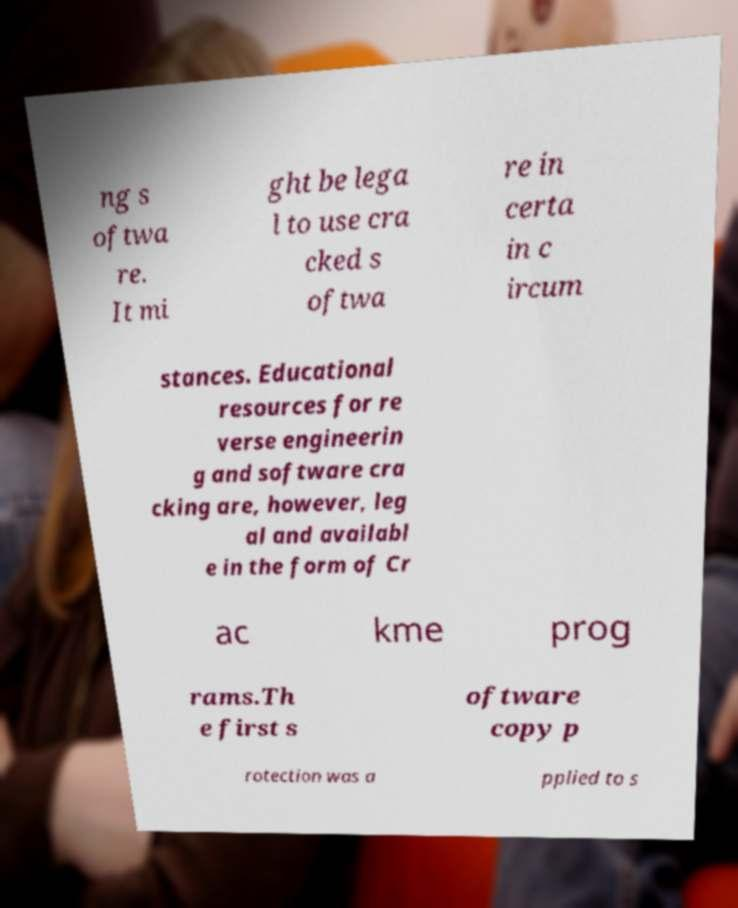Could you extract and type out the text from this image? ng s oftwa re. It mi ght be lega l to use cra cked s oftwa re in certa in c ircum stances. Educational resources for re verse engineerin g and software cra cking are, however, leg al and availabl e in the form of Cr ac kme prog rams.Th e first s oftware copy p rotection was a pplied to s 